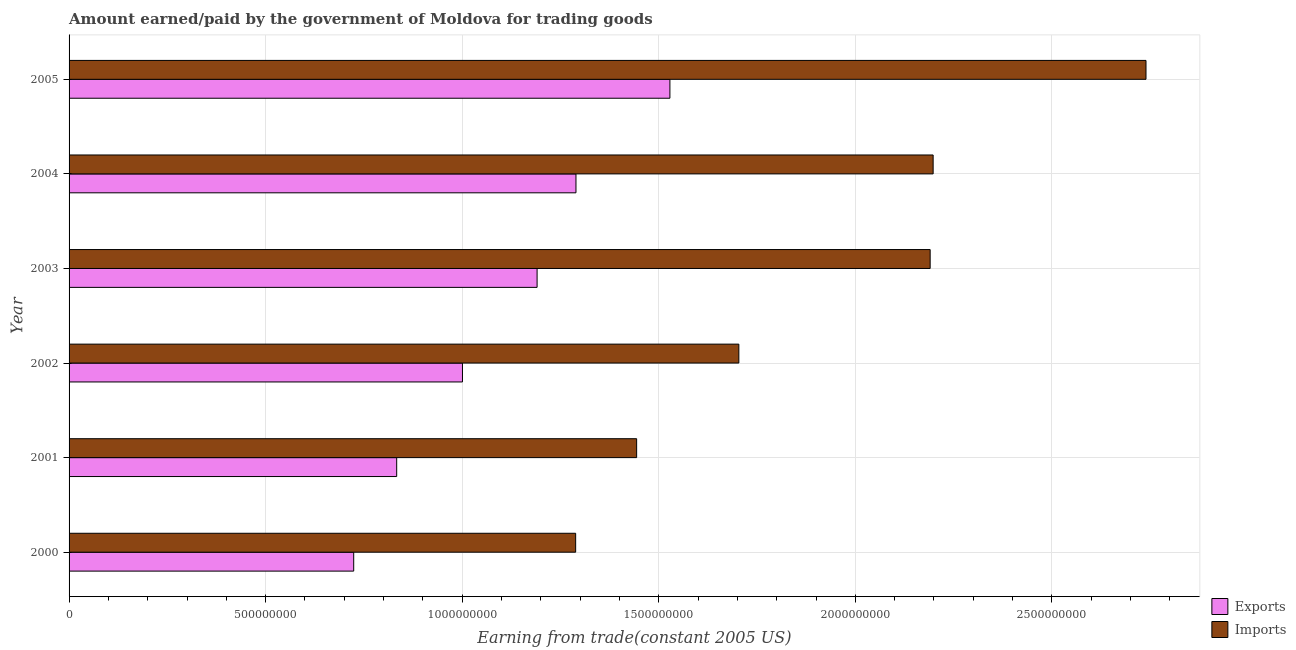Are the number of bars per tick equal to the number of legend labels?
Give a very brief answer. Yes. How many bars are there on the 6th tick from the bottom?
Keep it short and to the point. 2. In how many cases, is the number of bars for a given year not equal to the number of legend labels?
Give a very brief answer. 0. What is the amount earned from exports in 2000?
Your response must be concise. 7.24e+08. Across all years, what is the maximum amount earned from exports?
Offer a very short reply. 1.53e+09. Across all years, what is the minimum amount paid for imports?
Your response must be concise. 1.29e+09. In which year was the amount earned from exports minimum?
Make the answer very short. 2000. What is the total amount earned from exports in the graph?
Offer a very short reply. 6.57e+09. What is the difference between the amount paid for imports in 2003 and that in 2004?
Offer a terse response. -7.59e+06. What is the difference between the amount paid for imports in 2001 and the amount earned from exports in 2005?
Your answer should be very brief. -8.46e+07. What is the average amount earned from exports per year?
Provide a succinct answer. 1.09e+09. In the year 2004, what is the difference between the amount earned from exports and amount paid for imports?
Ensure brevity in your answer.  -9.09e+08. In how many years, is the amount paid for imports greater than 2200000000 US$?
Your answer should be compact. 1. What is the ratio of the amount paid for imports in 2001 to that in 2004?
Keep it short and to the point. 0.66. Is the difference between the amount paid for imports in 2003 and 2004 greater than the difference between the amount earned from exports in 2003 and 2004?
Provide a short and direct response. Yes. What is the difference between the highest and the second highest amount paid for imports?
Your answer should be compact. 5.41e+08. What is the difference between the highest and the lowest amount paid for imports?
Your answer should be very brief. 1.45e+09. In how many years, is the amount paid for imports greater than the average amount paid for imports taken over all years?
Offer a very short reply. 3. What does the 2nd bar from the top in 2004 represents?
Your answer should be compact. Exports. What does the 2nd bar from the bottom in 2003 represents?
Ensure brevity in your answer.  Imports. How many bars are there?
Provide a succinct answer. 12. Are all the bars in the graph horizontal?
Your answer should be very brief. Yes. Are the values on the major ticks of X-axis written in scientific E-notation?
Keep it short and to the point. No. Does the graph contain any zero values?
Give a very brief answer. No. Does the graph contain grids?
Give a very brief answer. Yes. Where does the legend appear in the graph?
Offer a very short reply. Bottom right. How are the legend labels stacked?
Provide a succinct answer. Vertical. What is the title of the graph?
Your response must be concise. Amount earned/paid by the government of Moldova for trading goods. Does "Export" appear as one of the legend labels in the graph?
Provide a succinct answer. No. What is the label or title of the X-axis?
Provide a short and direct response. Earning from trade(constant 2005 US). What is the Earning from trade(constant 2005 US) in Exports in 2000?
Provide a succinct answer. 7.24e+08. What is the Earning from trade(constant 2005 US) of Imports in 2000?
Give a very brief answer. 1.29e+09. What is the Earning from trade(constant 2005 US) of Exports in 2001?
Provide a succinct answer. 8.33e+08. What is the Earning from trade(constant 2005 US) in Imports in 2001?
Give a very brief answer. 1.44e+09. What is the Earning from trade(constant 2005 US) of Exports in 2002?
Provide a short and direct response. 1.00e+09. What is the Earning from trade(constant 2005 US) in Imports in 2002?
Keep it short and to the point. 1.70e+09. What is the Earning from trade(constant 2005 US) of Exports in 2003?
Make the answer very short. 1.19e+09. What is the Earning from trade(constant 2005 US) of Imports in 2003?
Offer a very short reply. 2.19e+09. What is the Earning from trade(constant 2005 US) in Exports in 2004?
Offer a terse response. 1.29e+09. What is the Earning from trade(constant 2005 US) in Imports in 2004?
Your answer should be compact. 2.20e+09. What is the Earning from trade(constant 2005 US) in Exports in 2005?
Ensure brevity in your answer.  1.53e+09. What is the Earning from trade(constant 2005 US) in Imports in 2005?
Offer a very short reply. 2.74e+09. Across all years, what is the maximum Earning from trade(constant 2005 US) in Exports?
Make the answer very short. 1.53e+09. Across all years, what is the maximum Earning from trade(constant 2005 US) in Imports?
Ensure brevity in your answer.  2.74e+09. Across all years, what is the minimum Earning from trade(constant 2005 US) in Exports?
Offer a very short reply. 7.24e+08. Across all years, what is the minimum Earning from trade(constant 2005 US) of Imports?
Provide a succinct answer. 1.29e+09. What is the total Earning from trade(constant 2005 US) of Exports in the graph?
Ensure brevity in your answer.  6.57e+09. What is the total Earning from trade(constant 2005 US) in Imports in the graph?
Ensure brevity in your answer.  1.16e+1. What is the difference between the Earning from trade(constant 2005 US) of Exports in 2000 and that in 2001?
Provide a succinct answer. -1.09e+08. What is the difference between the Earning from trade(constant 2005 US) of Imports in 2000 and that in 2001?
Keep it short and to the point. -1.55e+08. What is the difference between the Earning from trade(constant 2005 US) of Exports in 2000 and that in 2002?
Your response must be concise. -2.77e+08. What is the difference between the Earning from trade(constant 2005 US) in Imports in 2000 and that in 2002?
Offer a terse response. -4.15e+08. What is the difference between the Earning from trade(constant 2005 US) in Exports in 2000 and that in 2003?
Your answer should be very brief. -4.67e+08. What is the difference between the Earning from trade(constant 2005 US) in Imports in 2000 and that in 2003?
Make the answer very short. -9.02e+08. What is the difference between the Earning from trade(constant 2005 US) of Exports in 2000 and that in 2004?
Your response must be concise. -5.65e+08. What is the difference between the Earning from trade(constant 2005 US) of Imports in 2000 and that in 2004?
Keep it short and to the point. -9.09e+08. What is the difference between the Earning from trade(constant 2005 US) of Exports in 2000 and that in 2005?
Provide a short and direct response. -8.04e+08. What is the difference between the Earning from trade(constant 2005 US) of Imports in 2000 and that in 2005?
Keep it short and to the point. -1.45e+09. What is the difference between the Earning from trade(constant 2005 US) in Exports in 2001 and that in 2002?
Your answer should be compact. -1.67e+08. What is the difference between the Earning from trade(constant 2005 US) of Imports in 2001 and that in 2002?
Make the answer very short. -2.60e+08. What is the difference between the Earning from trade(constant 2005 US) in Exports in 2001 and that in 2003?
Offer a terse response. -3.57e+08. What is the difference between the Earning from trade(constant 2005 US) in Imports in 2001 and that in 2003?
Keep it short and to the point. -7.47e+08. What is the difference between the Earning from trade(constant 2005 US) of Exports in 2001 and that in 2004?
Your response must be concise. -4.56e+08. What is the difference between the Earning from trade(constant 2005 US) in Imports in 2001 and that in 2004?
Ensure brevity in your answer.  -7.54e+08. What is the difference between the Earning from trade(constant 2005 US) in Exports in 2001 and that in 2005?
Keep it short and to the point. -6.95e+08. What is the difference between the Earning from trade(constant 2005 US) of Imports in 2001 and that in 2005?
Keep it short and to the point. -1.30e+09. What is the difference between the Earning from trade(constant 2005 US) in Exports in 2002 and that in 2003?
Your answer should be compact. -1.90e+08. What is the difference between the Earning from trade(constant 2005 US) in Imports in 2002 and that in 2003?
Provide a succinct answer. -4.87e+08. What is the difference between the Earning from trade(constant 2005 US) of Exports in 2002 and that in 2004?
Ensure brevity in your answer.  -2.89e+08. What is the difference between the Earning from trade(constant 2005 US) in Imports in 2002 and that in 2004?
Provide a short and direct response. -4.94e+08. What is the difference between the Earning from trade(constant 2005 US) of Exports in 2002 and that in 2005?
Provide a short and direct response. -5.28e+08. What is the difference between the Earning from trade(constant 2005 US) of Imports in 2002 and that in 2005?
Provide a succinct answer. -1.04e+09. What is the difference between the Earning from trade(constant 2005 US) of Exports in 2003 and that in 2004?
Keep it short and to the point. -9.89e+07. What is the difference between the Earning from trade(constant 2005 US) in Imports in 2003 and that in 2004?
Give a very brief answer. -7.59e+06. What is the difference between the Earning from trade(constant 2005 US) in Exports in 2003 and that in 2005?
Your answer should be very brief. -3.38e+08. What is the difference between the Earning from trade(constant 2005 US) in Imports in 2003 and that in 2005?
Offer a very short reply. -5.49e+08. What is the difference between the Earning from trade(constant 2005 US) of Exports in 2004 and that in 2005?
Offer a terse response. -2.39e+08. What is the difference between the Earning from trade(constant 2005 US) in Imports in 2004 and that in 2005?
Keep it short and to the point. -5.41e+08. What is the difference between the Earning from trade(constant 2005 US) in Exports in 2000 and the Earning from trade(constant 2005 US) in Imports in 2001?
Offer a very short reply. -7.20e+08. What is the difference between the Earning from trade(constant 2005 US) of Exports in 2000 and the Earning from trade(constant 2005 US) of Imports in 2002?
Provide a short and direct response. -9.80e+08. What is the difference between the Earning from trade(constant 2005 US) in Exports in 2000 and the Earning from trade(constant 2005 US) in Imports in 2003?
Your answer should be compact. -1.47e+09. What is the difference between the Earning from trade(constant 2005 US) of Exports in 2000 and the Earning from trade(constant 2005 US) of Imports in 2004?
Offer a very short reply. -1.47e+09. What is the difference between the Earning from trade(constant 2005 US) in Exports in 2000 and the Earning from trade(constant 2005 US) in Imports in 2005?
Offer a terse response. -2.02e+09. What is the difference between the Earning from trade(constant 2005 US) in Exports in 2001 and the Earning from trade(constant 2005 US) in Imports in 2002?
Your response must be concise. -8.70e+08. What is the difference between the Earning from trade(constant 2005 US) in Exports in 2001 and the Earning from trade(constant 2005 US) in Imports in 2003?
Provide a short and direct response. -1.36e+09. What is the difference between the Earning from trade(constant 2005 US) in Exports in 2001 and the Earning from trade(constant 2005 US) in Imports in 2004?
Your response must be concise. -1.36e+09. What is the difference between the Earning from trade(constant 2005 US) in Exports in 2001 and the Earning from trade(constant 2005 US) in Imports in 2005?
Provide a short and direct response. -1.91e+09. What is the difference between the Earning from trade(constant 2005 US) in Exports in 2002 and the Earning from trade(constant 2005 US) in Imports in 2003?
Your answer should be compact. -1.19e+09. What is the difference between the Earning from trade(constant 2005 US) in Exports in 2002 and the Earning from trade(constant 2005 US) in Imports in 2004?
Your answer should be compact. -1.20e+09. What is the difference between the Earning from trade(constant 2005 US) of Exports in 2002 and the Earning from trade(constant 2005 US) of Imports in 2005?
Keep it short and to the point. -1.74e+09. What is the difference between the Earning from trade(constant 2005 US) in Exports in 2003 and the Earning from trade(constant 2005 US) in Imports in 2004?
Provide a short and direct response. -1.01e+09. What is the difference between the Earning from trade(constant 2005 US) in Exports in 2003 and the Earning from trade(constant 2005 US) in Imports in 2005?
Your answer should be compact. -1.55e+09. What is the difference between the Earning from trade(constant 2005 US) of Exports in 2004 and the Earning from trade(constant 2005 US) of Imports in 2005?
Ensure brevity in your answer.  -1.45e+09. What is the average Earning from trade(constant 2005 US) of Exports per year?
Provide a succinct answer. 1.09e+09. What is the average Earning from trade(constant 2005 US) of Imports per year?
Your answer should be very brief. 1.93e+09. In the year 2000, what is the difference between the Earning from trade(constant 2005 US) in Exports and Earning from trade(constant 2005 US) in Imports?
Make the answer very short. -5.65e+08. In the year 2001, what is the difference between the Earning from trade(constant 2005 US) in Exports and Earning from trade(constant 2005 US) in Imports?
Offer a very short reply. -6.10e+08. In the year 2002, what is the difference between the Earning from trade(constant 2005 US) of Exports and Earning from trade(constant 2005 US) of Imports?
Offer a very short reply. -7.03e+08. In the year 2003, what is the difference between the Earning from trade(constant 2005 US) in Exports and Earning from trade(constant 2005 US) in Imports?
Ensure brevity in your answer.  -1.00e+09. In the year 2004, what is the difference between the Earning from trade(constant 2005 US) in Exports and Earning from trade(constant 2005 US) in Imports?
Your answer should be compact. -9.09e+08. In the year 2005, what is the difference between the Earning from trade(constant 2005 US) in Exports and Earning from trade(constant 2005 US) in Imports?
Your answer should be compact. -1.21e+09. What is the ratio of the Earning from trade(constant 2005 US) of Exports in 2000 to that in 2001?
Provide a short and direct response. 0.87. What is the ratio of the Earning from trade(constant 2005 US) of Imports in 2000 to that in 2001?
Your answer should be very brief. 0.89. What is the ratio of the Earning from trade(constant 2005 US) in Exports in 2000 to that in 2002?
Give a very brief answer. 0.72. What is the ratio of the Earning from trade(constant 2005 US) in Imports in 2000 to that in 2002?
Ensure brevity in your answer.  0.76. What is the ratio of the Earning from trade(constant 2005 US) in Exports in 2000 to that in 2003?
Give a very brief answer. 0.61. What is the ratio of the Earning from trade(constant 2005 US) in Imports in 2000 to that in 2003?
Offer a terse response. 0.59. What is the ratio of the Earning from trade(constant 2005 US) in Exports in 2000 to that in 2004?
Your answer should be very brief. 0.56. What is the ratio of the Earning from trade(constant 2005 US) in Imports in 2000 to that in 2004?
Keep it short and to the point. 0.59. What is the ratio of the Earning from trade(constant 2005 US) of Exports in 2000 to that in 2005?
Provide a short and direct response. 0.47. What is the ratio of the Earning from trade(constant 2005 US) of Imports in 2000 to that in 2005?
Provide a short and direct response. 0.47. What is the ratio of the Earning from trade(constant 2005 US) of Exports in 2001 to that in 2002?
Provide a succinct answer. 0.83. What is the ratio of the Earning from trade(constant 2005 US) of Imports in 2001 to that in 2002?
Offer a very short reply. 0.85. What is the ratio of the Earning from trade(constant 2005 US) in Exports in 2001 to that in 2003?
Offer a very short reply. 0.7. What is the ratio of the Earning from trade(constant 2005 US) of Imports in 2001 to that in 2003?
Provide a short and direct response. 0.66. What is the ratio of the Earning from trade(constant 2005 US) in Exports in 2001 to that in 2004?
Your answer should be compact. 0.65. What is the ratio of the Earning from trade(constant 2005 US) of Imports in 2001 to that in 2004?
Your answer should be very brief. 0.66. What is the ratio of the Earning from trade(constant 2005 US) in Exports in 2001 to that in 2005?
Give a very brief answer. 0.55. What is the ratio of the Earning from trade(constant 2005 US) of Imports in 2001 to that in 2005?
Keep it short and to the point. 0.53. What is the ratio of the Earning from trade(constant 2005 US) in Exports in 2002 to that in 2003?
Your response must be concise. 0.84. What is the ratio of the Earning from trade(constant 2005 US) of Imports in 2002 to that in 2003?
Offer a very short reply. 0.78. What is the ratio of the Earning from trade(constant 2005 US) of Exports in 2002 to that in 2004?
Your answer should be very brief. 0.78. What is the ratio of the Earning from trade(constant 2005 US) in Imports in 2002 to that in 2004?
Provide a succinct answer. 0.78. What is the ratio of the Earning from trade(constant 2005 US) of Exports in 2002 to that in 2005?
Make the answer very short. 0.65. What is the ratio of the Earning from trade(constant 2005 US) in Imports in 2002 to that in 2005?
Provide a short and direct response. 0.62. What is the ratio of the Earning from trade(constant 2005 US) in Exports in 2003 to that in 2004?
Your answer should be very brief. 0.92. What is the ratio of the Earning from trade(constant 2005 US) of Exports in 2003 to that in 2005?
Make the answer very short. 0.78. What is the ratio of the Earning from trade(constant 2005 US) in Imports in 2003 to that in 2005?
Provide a short and direct response. 0.8. What is the ratio of the Earning from trade(constant 2005 US) in Exports in 2004 to that in 2005?
Your answer should be compact. 0.84. What is the ratio of the Earning from trade(constant 2005 US) of Imports in 2004 to that in 2005?
Make the answer very short. 0.8. What is the difference between the highest and the second highest Earning from trade(constant 2005 US) of Exports?
Give a very brief answer. 2.39e+08. What is the difference between the highest and the second highest Earning from trade(constant 2005 US) in Imports?
Ensure brevity in your answer.  5.41e+08. What is the difference between the highest and the lowest Earning from trade(constant 2005 US) in Exports?
Offer a very short reply. 8.04e+08. What is the difference between the highest and the lowest Earning from trade(constant 2005 US) in Imports?
Provide a short and direct response. 1.45e+09. 